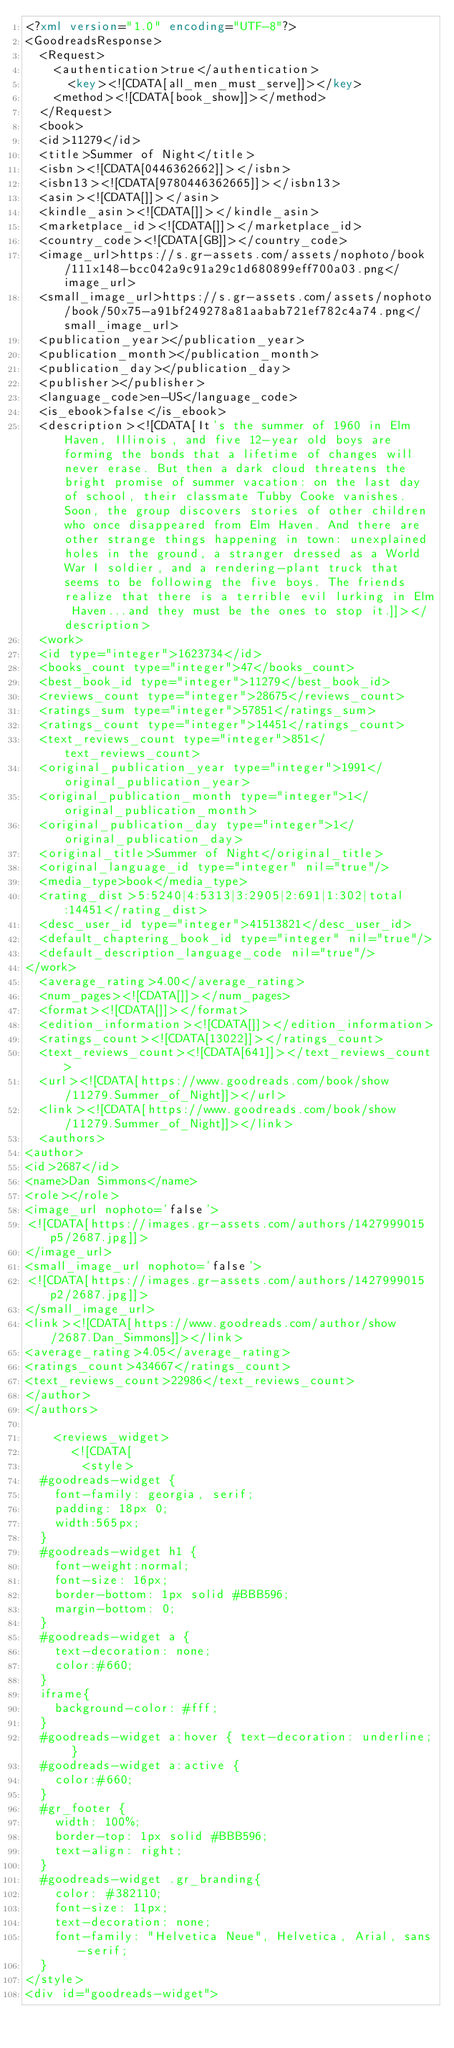Convert code to text. <code><loc_0><loc_0><loc_500><loc_500><_XML_><?xml version="1.0" encoding="UTF-8"?>
<GoodreadsResponse>
  <Request>
    <authentication>true</authentication>
      <key><![CDATA[all_men_must_serve]]></key>
    <method><![CDATA[book_show]]></method>
  </Request>
  <book>
  <id>11279</id>
  <title>Summer of Night</title>
  <isbn><![CDATA[0446362662]]></isbn>
  <isbn13><![CDATA[9780446362665]]></isbn13>
  <asin><![CDATA[]]></asin>
  <kindle_asin><![CDATA[]]></kindle_asin>
  <marketplace_id><![CDATA[]]></marketplace_id>
  <country_code><![CDATA[GB]]></country_code>
  <image_url>https://s.gr-assets.com/assets/nophoto/book/111x148-bcc042a9c91a29c1d680899eff700a03.png</image_url>
  <small_image_url>https://s.gr-assets.com/assets/nophoto/book/50x75-a91bf249278a81aabab721ef782c4a74.png</small_image_url>
  <publication_year></publication_year>
  <publication_month></publication_month>
  <publication_day></publication_day>
  <publisher></publisher>
  <language_code>en-US</language_code>
  <is_ebook>false</is_ebook>
  <description><![CDATA[It's the summer of 1960 in Elm Haven, Illinois, and five 12-year old boys are forming the bonds that a lifetime of changes will never erase. But then a dark cloud threatens the bright promise of summer vacation: on the last day of school, their classmate Tubby Cooke vanishes. Soon, the group discovers stories of other children who once disappeared from Elm Haven. And there are other strange things happening in town: unexplained holes in the ground, a stranger dressed as a World War I soldier, and a rendering-plant truck that seems to be following the five boys. The friends realize that there is a terrible evil lurking in Elm Haven...and they must be the ones to stop it.]]></description>
  <work>
  <id type="integer">1623734</id>
  <books_count type="integer">47</books_count>
  <best_book_id type="integer">11279</best_book_id>
  <reviews_count type="integer">28675</reviews_count>
  <ratings_sum type="integer">57851</ratings_sum>
  <ratings_count type="integer">14451</ratings_count>
  <text_reviews_count type="integer">851</text_reviews_count>
  <original_publication_year type="integer">1991</original_publication_year>
  <original_publication_month type="integer">1</original_publication_month>
  <original_publication_day type="integer">1</original_publication_day>
  <original_title>Summer of Night</original_title>
  <original_language_id type="integer" nil="true"/>
  <media_type>book</media_type>
  <rating_dist>5:5240|4:5313|3:2905|2:691|1:302|total:14451</rating_dist>
  <desc_user_id type="integer">41513821</desc_user_id>
  <default_chaptering_book_id type="integer" nil="true"/>
  <default_description_language_code nil="true"/>
</work>
  <average_rating>4.00</average_rating>
  <num_pages><![CDATA[]]></num_pages>
  <format><![CDATA[]]></format>
  <edition_information><![CDATA[]]></edition_information>
  <ratings_count><![CDATA[13022]]></ratings_count>
  <text_reviews_count><![CDATA[641]]></text_reviews_count>
  <url><![CDATA[https://www.goodreads.com/book/show/11279.Summer_of_Night]]></url>
  <link><![CDATA[https://www.goodreads.com/book/show/11279.Summer_of_Night]]></link>
  <authors>
<author>
<id>2687</id>
<name>Dan Simmons</name>
<role></role>
<image_url nophoto='false'>
<![CDATA[https://images.gr-assets.com/authors/1427999015p5/2687.jpg]]>
</image_url>
<small_image_url nophoto='false'>
<![CDATA[https://images.gr-assets.com/authors/1427999015p2/2687.jpg]]>
</small_image_url>
<link><![CDATA[https://www.goodreads.com/author/show/2687.Dan_Simmons]]></link>
<average_rating>4.05</average_rating>
<ratings_count>434667</ratings_count>
<text_reviews_count>22986</text_reviews_count>
</author>
</authors>

    <reviews_widget>
      <![CDATA[
        <style>
  #goodreads-widget {
    font-family: georgia, serif;
    padding: 18px 0;
    width:565px;
  }
  #goodreads-widget h1 {
    font-weight:normal;
    font-size: 16px;
    border-bottom: 1px solid #BBB596;
    margin-bottom: 0;
  }
  #goodreads-widget a {
    text-decoration: none;
    color:#660;
  }
  iframe{
    background-color: #fff;
  }
  #goodreads-widget a:hover { text-decoration: underline; }
  #goodreads-widget a:active {
    color:#660;
  }
  #gr_footer {
    width: 100%;
    border-top: 1px solid #BBB596;
    text-align: right;
  }
  #goodreads-widget .gr_branding{
    color: #382110;
    font-size: 11px;
    text-decoration: none;
    font-family: "Helvetica Neue", Helvetica, Arial, sans-serif;
  }
</style>
<div id="goodreads-widget"></code> 